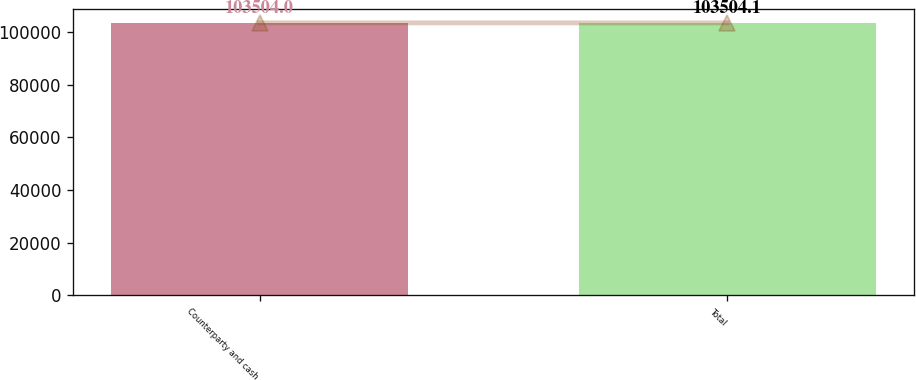Convert chart to OTSL. <chart><loc_0><loc_0><loc_500><loc_500><bar_chart><fcel>Counterparty and cash<fcel>Total<nl><fcel>103504<fcel>103504<nl></chart> 